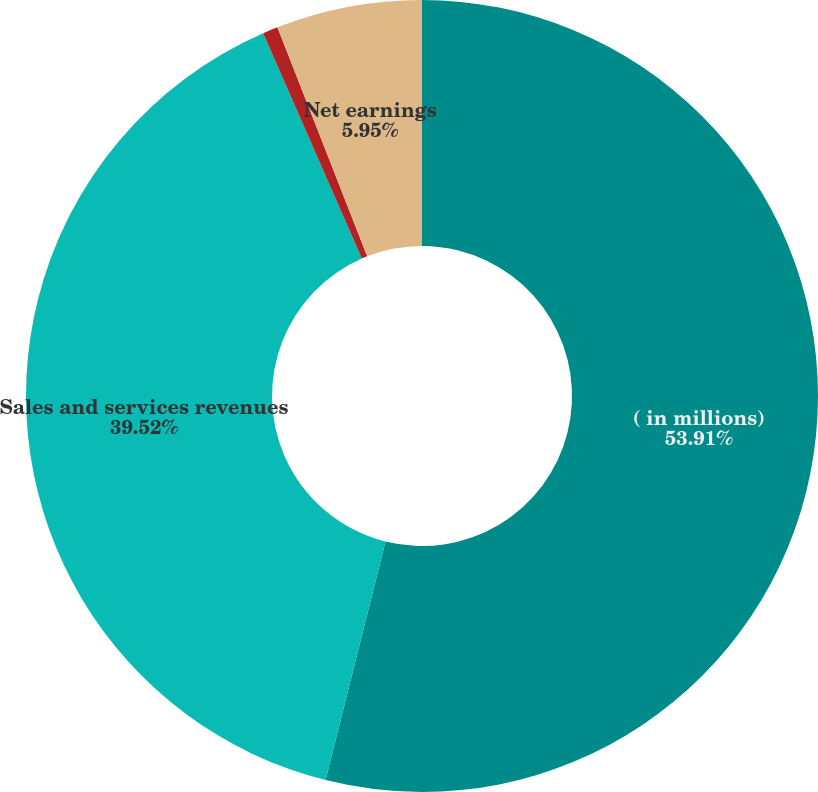<chart> <loc_0><loc_0><loc_500><loc_500><pie_chart><fcel>( in millions)<fcel>Sales and services revenues<fcel>Operating income<fcel>Net earnings<nl><fcel>53.92%<fcel>39.52%<fcel>0.62%<fcel>5.95%<nl></chart> 